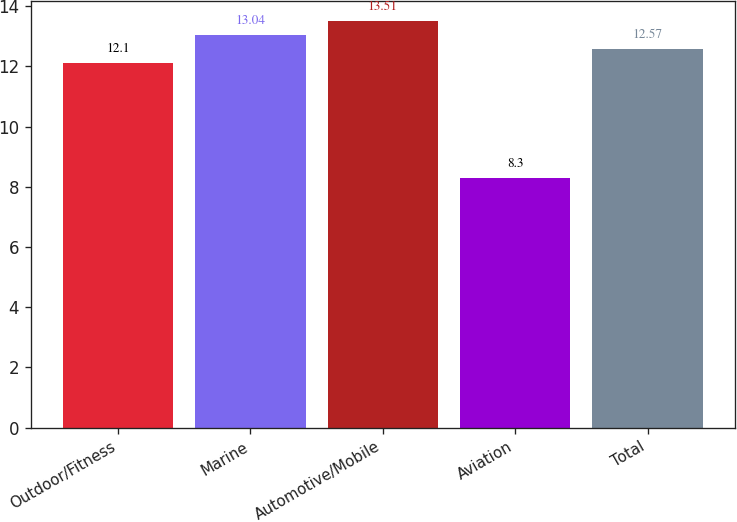Convert chart to OTSL. <chart><loc_0><loc_0><loc_500><loc_500><bar_chart><fcel>Outdoor/Fitness<fcel>Marine<fcel>Automotive/Mobile<fcel>Aviation<fcel>Total<nl><fcel>12.1<fcel>13.04<fcel>13.51<fcel>8.3<fcel>12.57<nl></chart> 